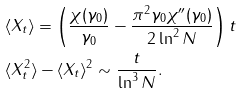<formula> <loc_0><loc_0><loc_500><loc_500>& \langle X _ { t } \rangle = \left ( \frac { \chi ( \gamma _ { 0 } ) } { \gamma _ { 0 } } - \frac { \pi ^ { 2 } \gamma _ { 0 } \chi ^ { \prime \prime } ( \gamma _ { 0 } ) } { 2 \ln ^ { 2 } N } \right ) t \\ & \langle X _ { t } ^ { 2 } \rangle - \langle X _ { t } \rangle ^ { 2 } \sim \frac { t } { \ln ^ { 3 } N } .</formula> 